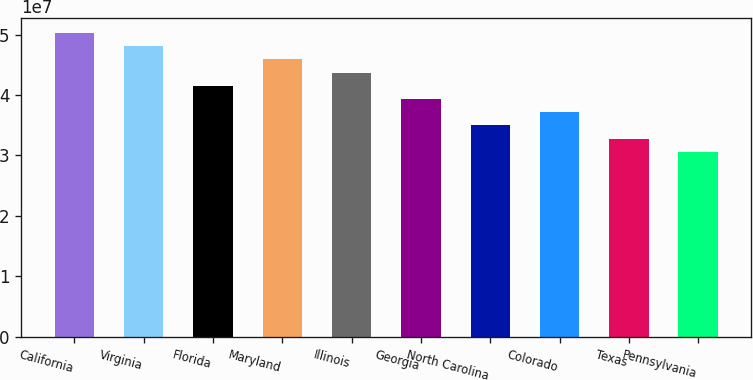Convert chart. <chart><loc_0><loc_0><loc_500><loc_500><bar_chart><fcel>California<fcel>Virginia<fcel>Florida<fcel>Maryland<fcel>Illinois<fcel>Georgia<fcel>North Carolina<fcel>Colorado<fcel>Texas<fcel>Pennsylvania<nl><fcel>5.02581e+07<fcel>4.80737e+07<fcel>4.15205e+07<fcel>4.58893e+07<fcel>4.37049e+07<fcel>3.93361e+07<fcel>3.49673e+07<fcel>3.71517e+07<fcel>3.27829e+07<fcel>3.05985e+07<nl></chart> 